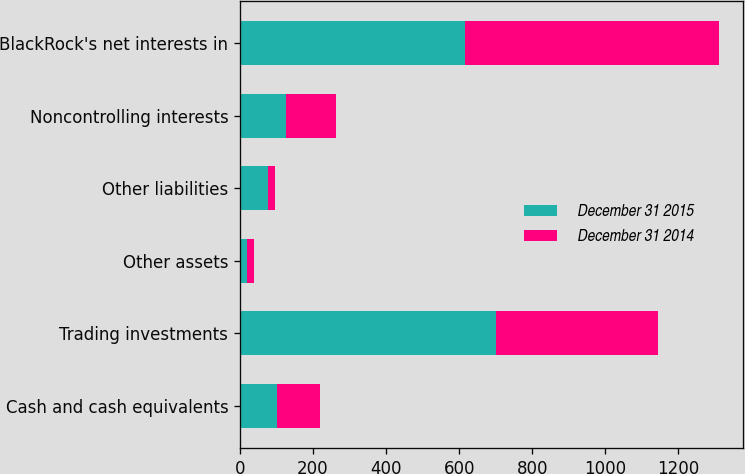<chart> <loc_0><loc_0><loc_500><loc_500><stacked_bar_chart><ecel><fcel>Cash and cash equivalents<fcel>Trading investments<fcel>Other assets<fcel>Other liabilities<fcel>Noncontrolling interests<fcel>BlackRock's net interests in<nl><fcel>December 31 2015<fcel>100<fcel>700<fcel>18<fcel>77<fcel>125<fcel>616<nl><fcel>December 31 2014<fcel>120<fcel>443<fcel>20<fcel>18<fcel>139<fcel>696<nl></chart> 